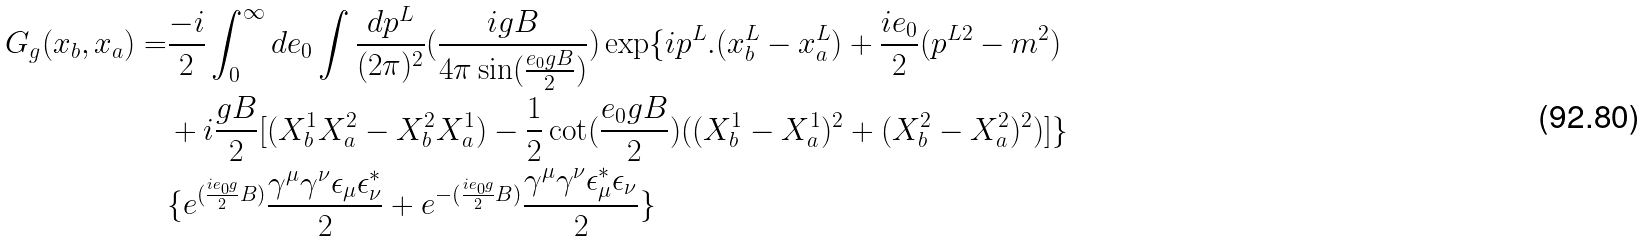Convert formula to latex. <formula><loc_0><loc_0><loc_500><loc_500>G _ { g } ( x _ { b } , x _ { a } ) = & \frac { - i } { 2 } \int _ { 0 } ^ { \infty } d e _ { 0 } \int \frac { d p ^ { L } } { ( 2 \pi ) ^ { 2 } } ( \frac { i g B } { 4 \pi \sin ( \frac { e _ { 0 } g B } { 2 } ) } ) \exp \{ i p ^ { L } . ( x _ { b } ^ { L } - x _ { a } ^ { L } ) + \frac { i e _ { 0 } } { 2 } ( p ^ { L 2 } - m ^ { 2 } ) \\ & + i \frac { g B } { 2 } [ ( X _ { b } ^ { 1 } X _ { a } ^ { 2 } - X _ { b } ^ { 2 } X _ { a } ^ { 1 } ) - \frac { 1 } { 2 } \cot ( \frac { e _ { 0 } g B } { 2 } ) ( ( X _ { b } ^ { 1 } - X _ { a } ^ { 1 } ) ^ { 2 } + ( X _ { b } ^ { 2 } - X _ { a } ^ { 2 } ) ^ { 2 } ) ] \} \\ & \{ e ^ { ( \frac { i e _ { 0 } g } { 2 } B ) } \frac { \gamma ^ { \mu } \gamma ^ { \nu } \epsilon _ { \mu } \epsilon ^ { * } _ { \nu } } { 2 } + e ^ { - ( \frac { i e _ { 0 } g } { 2 } B ) } \frac { \gamma ^ { \mu } \gamma ^ { \nu } \epsilon ^ { * } _ { \mu } \epsilon _ { \nu } } { 2 } \}</formula> 